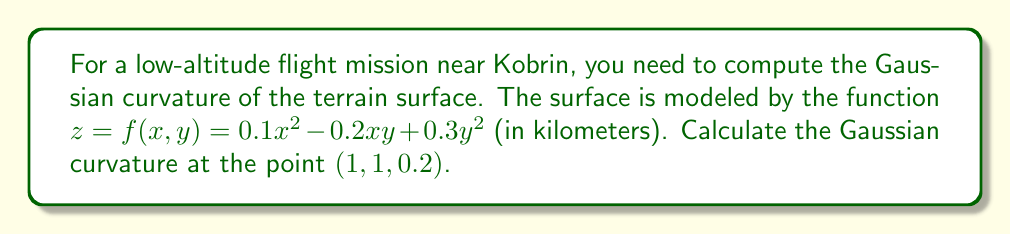Solve this math problem. To compute the Gaussian curvature of a surface $z = f(x,y)$ at a point, we follow these steps:

1) First, we need to calculate the first and second partial derivatives of $f(x,y)$:

   $f_x = 0.2x - 0.2y$
   $f_y = -0.2x + 0.6y$
   $f_{xx} = 0.2$
   $f_{yy} = 0.6$
   $f_{xy} = f_{yx} = -0.2$

2) The Gaussian curvature $K$ is given by the formula:

   $$K = \frac{f_{xx}f_{yy} - f_{xy}^2}{(1 + f_x^2 + f_y^2)^2}$$

3) At the point (1, 1, 0.2), we evaluate:

   $f_x(1,1) = 0.2 - 0.2 = 0$
   $f_y(1,1) = -0.2 + 0.6 = 0.4$

4) Now we can substitute all values into the formula:

   $$K = \frac{(0.2)(0.6) - (-0.2)^2}{(1 + 0^2 + 0.4^2)^2}$$

5) Simplify:

   $$K = \frac{0.12 - 0.04}{(1 + 0.16)^2} = \frac{0.08}{1.3456}$$

6) Calculate the final result:

   $$K \approx 0.0595 \text{ km}^{-2}$$
Answer: $0.0595 \text{ km}^{-2}$ 